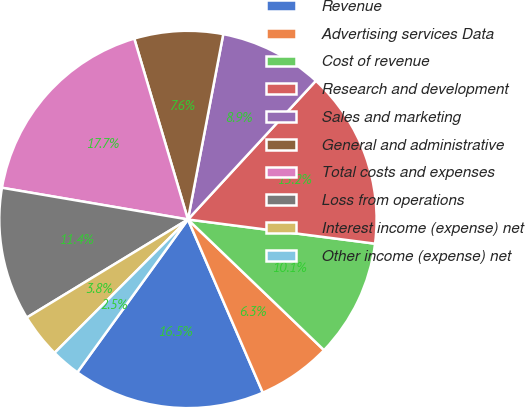Convert chart. <chart><loc_0><loc_0><loc_500><loc_500><pie_chart><fcel>Revenue<fcel>Advertising services Data<fcel>Cost of revenue<fcel>Research and development<fcel>Sales and marketing<fcel>General and administrative<fcel>Total costs and expenses<fcel>Loss from operations<fcel>Interest income (expense) net<fcel>Other income (expense) net<nl><fcel>16.46%<fcel>6.33%<fcel>10.13%<fcel>15.19%<fcel>8.86%<fcel>7.59%<fcel>17.72%<fcel>11.39%<fcel>3.8%<fcel>2.53%<nl></chart> 